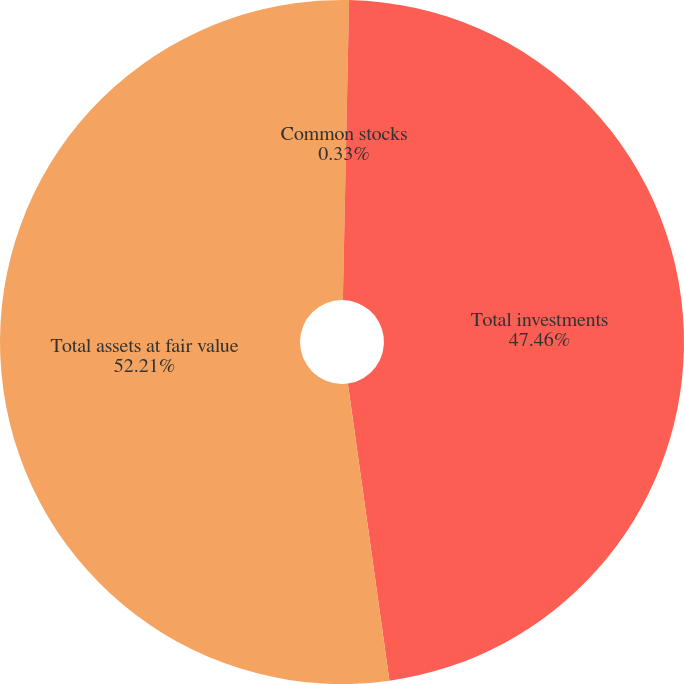<chart> <loc_0><loc_0><loc_500><loc_500><pie_chart><fcel>Common stocks<fcel>Total investments<fcel>Total assets at fair value<nl><fcel>0.33%<fcel>47.46%<fcel>52.22%<nl></chart> 